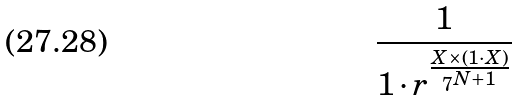Convert formula to latex. <formula><loc_0><loc_0><loc_500><loc_500>\frac { 1 } { 1 \cdot r ^ { \frac { X \times ( 1 \cdot X ) } { 7 ^ { N + 1 } } } }</formula> 